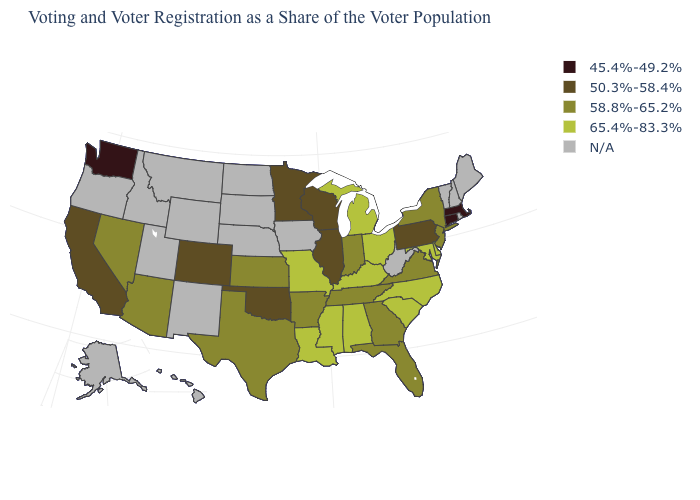Name the states that have a value in the range 50.3%-58.4%?
Give a very brief answer. California, Colorado, Illinois, Minnesota, Oklahoma, Pennsylvania, Wisconsin. Name the states that have a value in the range N/A?
Answer briefly. Alaska, Hawaii, Idaho, Iowa, Maine, Montana, Nebraska, New Hampshire, New Mexico, North Dakota, Oregon, Rhode Island, South Dakota, Utah, Vermont, West Virginia, Wyoming. What is the value of Idaho?
Answer briefly. N/A. Does the map have missing data?
Keep it brief. Yes. What is the value of Montana?
Write a very short answer. N/A. Which states have the highest value in the USA?
Concise answer only. Alabama, Delaware, Kentucky, Louisiana, Maryland, Michigan, Mississippi, Missouri, North Carolina, Ohio, South Carolina. Name the states that have a value in the range 45.4%-49.2%?
Be succinct. Connecticut, Massachusetts, Washington. What is the value of Nebraska?
Keep it brief. N/A. Name the states that have a value in the range N/A?
Be succinct. Alaska, Hawaii, Idaho, Iowa, Maine, Montana, Nebraska, New Hampshire, New Mexico, North Dakota, Oregon, Rhode Island, South Dakota, Utah, Vermont, West Virginia, Wyoming. Does the first symbol in the legend represent the smallest category?
Write a very short answer. Yes. What is the value of Georgia?
Give a very brief answer. 58.8%-65.2%. Name the states that have a value in the range 50.3%-58.4%?
Concise answer only. California, Colorado, Illinois, Minnesota, Oklahoma, Pennsylvania, Wisconsin. What is the value of Arkansas?
Quick response, please. 58.8%-65.2%. Among the states that border New Jersey , which have the lowest value?
Concise answer only. Pennsylvania. What is the lowest value in states that border Rhode Island?
Concise answer only. 45.4%-49.2%. 